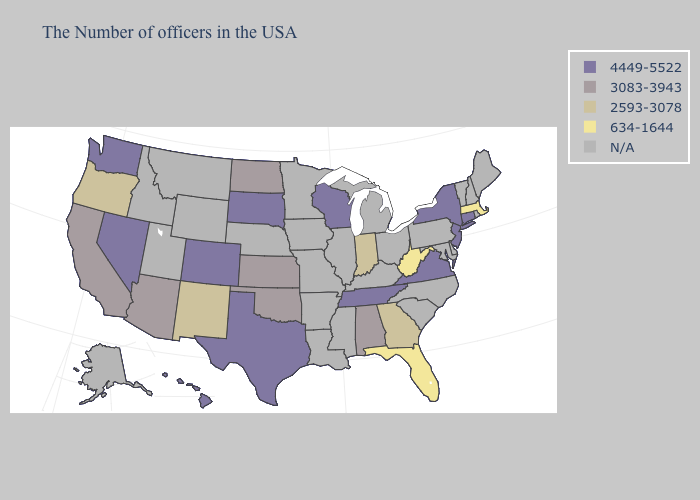Name the states that have a value in the range 2593-3078?
Answer briefly. Georgia, Indiana, New Mexico, Oregon. Name the states that have a value in the range N/A?
Write a very short answer. Maine, Rhode Island, New Hampshire, Vermont, Delaware, Maryland, Pennsylvania, North Carolina, South Carolina, Ohio, Michigan, Kentucky, Illinois, Mississippi, Louisiana, Missouri, Arkansas, Minnesota, Iowa, Nebraska, Wyoming, Utah, Montana, Idaho, Alaska. Name the states that have a value in the range 4449-5522?
Give a very brief answer. Connecticut, New York, New Jersey, Virginia, Tennessee, Wisconsin, Texas, South Dakota, Colorado, Nevada, Washington, Hawaii. Among the states that border South Dakota , which have the highest value?
Concise answer only. North Dakota. Is the legend a continuous bar?
Be succinct. No. Which states have the lowest value in the MidWest?
Give a very brief answer. Indiana. Does New York have the highest value in the Northeast?
Keep it brief. Yes. Name the states that have a value in the range 2593-3078?
Keep it brief. Georgia, Indiana, New Mexico, Oregon. What is the highest value in the West ?
Concise answer only. 4449-5522. What is the highest value in the West ?
Give a very brief answer. 4449-5522. Which states have the lowest value in the USA?
Answer briefly. Massachusetts, West Virginia, Florida. Among the states that border North Dakota , which have the lowest value?
Write a very short answer. South Dakota. What is the highest value in states that border New York?
Keep it brief. 4449-5522. Name the states that have a value in the range 634-1644?
Keep it brief. Massachusetts, West Virginia, Florida. What is the value of Hawaii?
Be succinct. 4449-5522. 